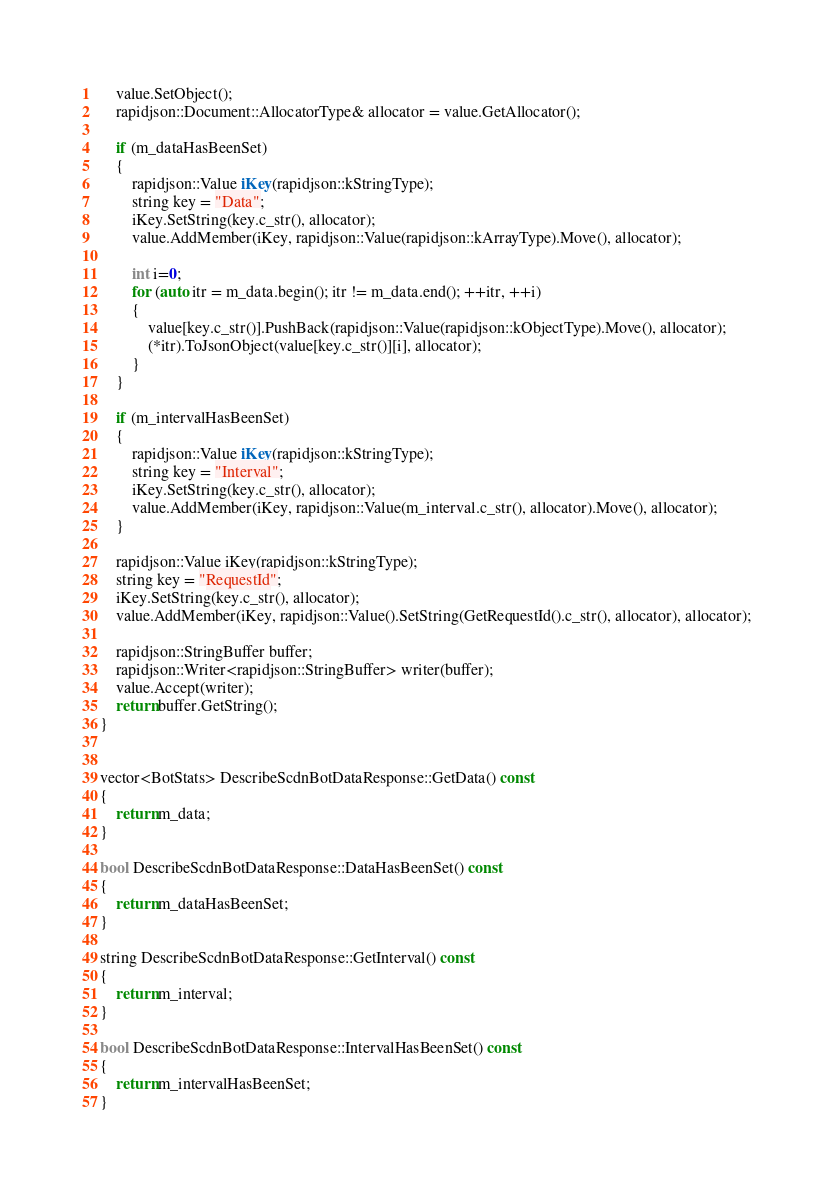Convert code to text. <code><loc_0><loc_0><loc_500><loc_500><_C++_>    value.SetObject();
    rapidjson::Document::AllocatorType& allocator = value.GetAllocator();

    if (m_dataHasBeenSet)
    {
        rapidjson::Value iKey(rapidjson::kStringType);
        string key = "Data";
        iKey.SetString(key.c_str(), allocator);
        value.AddMember(iKey, rapidjson::Value(rapidjson::kArrayType).Move(), allocator);

        int i=0;
        for (auto itr = m_data.begin(); itr != m_data.end(); ++itr, ++i)
        {
            value[key.c_str()].PushBack(rapidjson::Value(rapidjson::kObjectType).Move(), allocator);
            (*itr).ToJsonObject(value[key.c_str()][i], allocator);
        }
    }

    if (m_intervalHasBeenSet)
    {
        rapidjson::Value iKey(rapidjson::kStringType);
        string key = "Interval";
        iKey.SetString(key.c_str(), allocator);
        value.AddMember(iKey, rapidjson::Value(m_interval.c_str(), allocator).Move(), allocator);
    }

    rapidjson::Value iKey(rapidjson::kStringType);
    string key = "RequestId";
    iKey.SetString(key.c_str(), allocator);
    value.AddMember(iKey, rapidjson::Value().SetString(GetRequestId().c_str(), allocator), allocator);
    
    rapidjson::StringBuffer buffer;
    rapidjson::Writer<rapidjson::StringBuffer> writer(buffer);
    value.Accept(writer);
    return buffer.GetString();
}


vector<BotStats> DescribeScdnBotDataResponse::GetData() const
{
    return m_data;
}

bool DescribeScdnBotDataResponse::DataHasBeenSet() const
{
    return m_dataHasBeenSet;
}

string DescribeScdnBotDataResponse::GetInterval() const
{
    return m_interval;
}

bool DescribeScdnBotDataResponse::IntervalHasBeenSet() const
{
    return m_intervalHasBeenSet;
}


</code> 